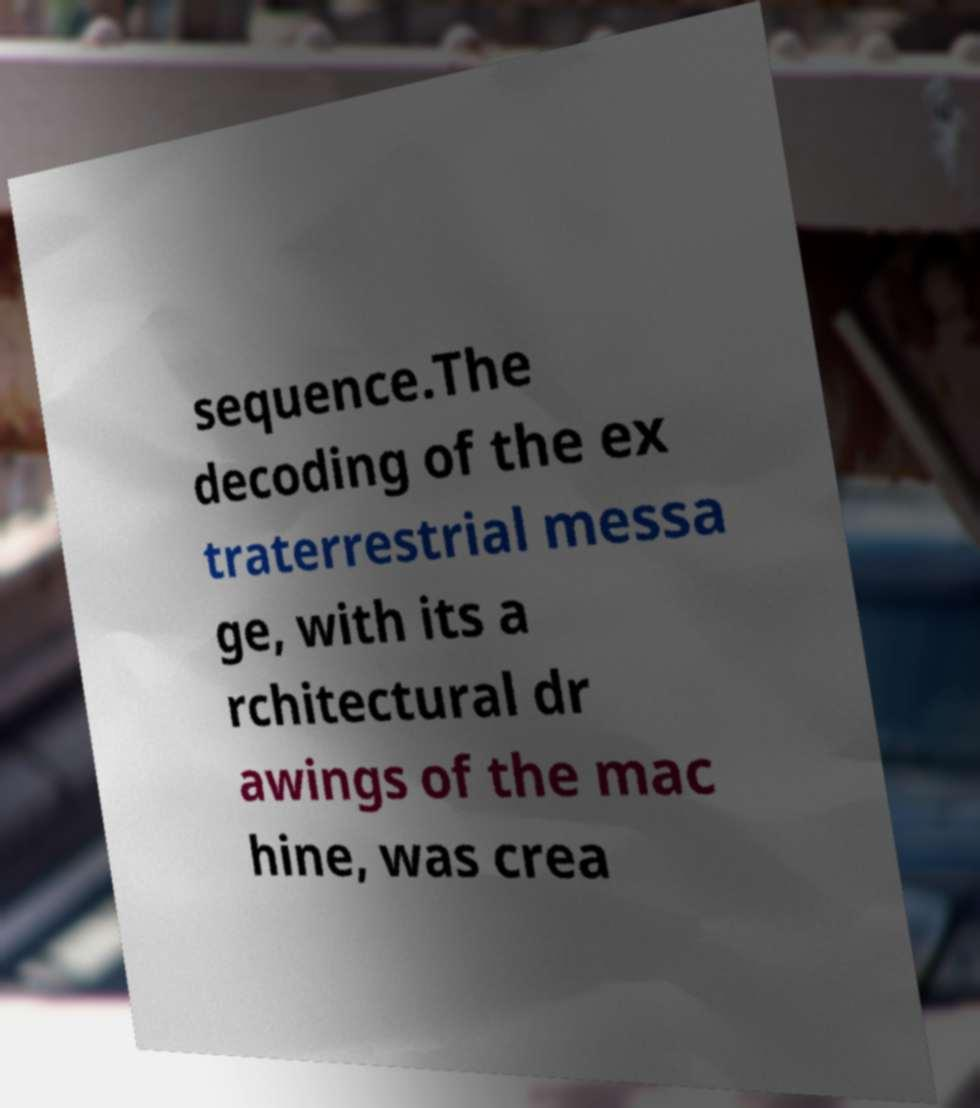Please read and relay the text visible in this image. What does it say? sequence.The decoding of the ex traterrestrial messa ge, with its a rchitectural dr awings of the mac hine, was crea 